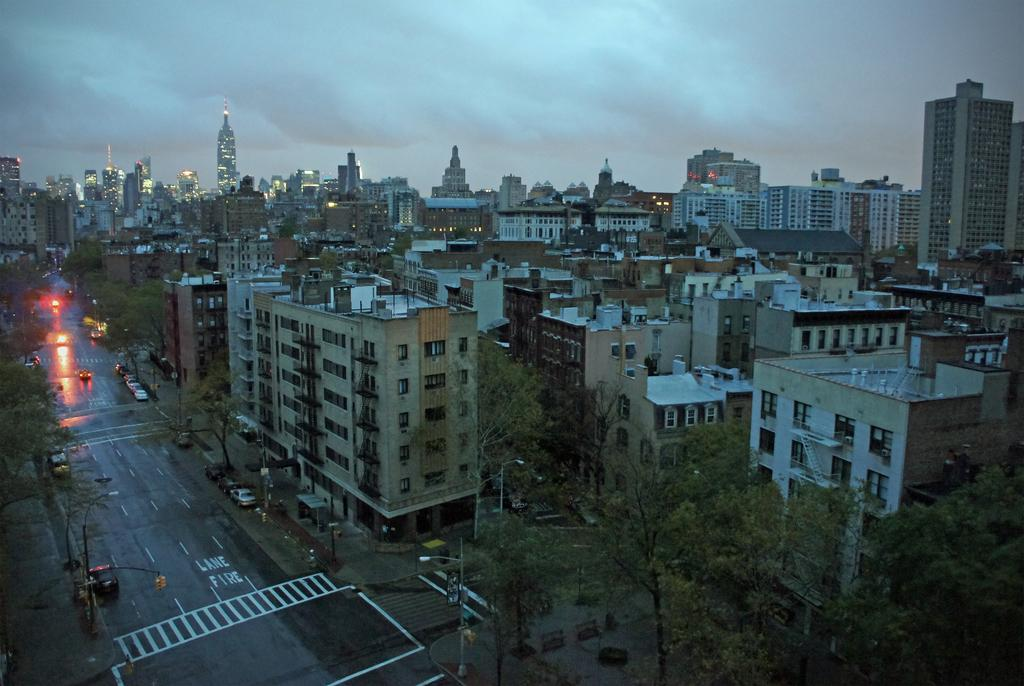What type of structures can be seen in the image? There are buildings in the image. What else can be seen illuminating the area in the image? There are light poles in the image. What mode of transportation can be seen on the road in the image? There are vehicles on the road in the image. What type of vegetation is present in the image? There are trees in the image. What is visible above the structures and vehicles in the image? The sky is visible in the image. What type of meal is being prepared in the image? There is no meal preparation visible in the image; it features buildings, light poles, vehicles, trees, and the sky. What nerve is responsible for the movement of the trees in the image? There is no nerve involved in the movement of the trees in the image, as they are stationary. 